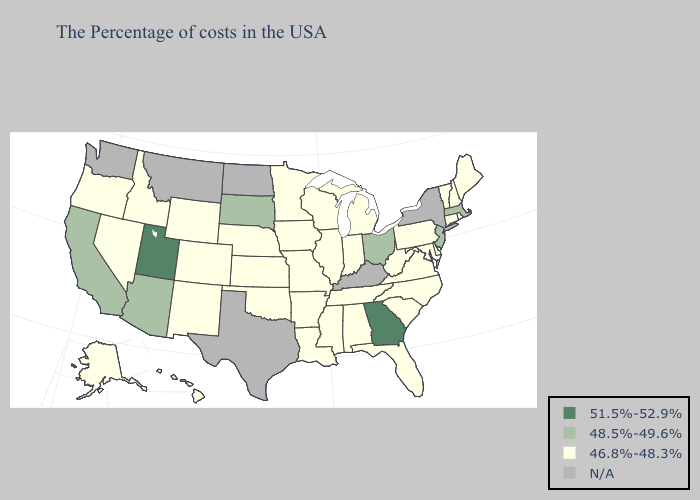What is the value of Georgia?
Keep it brief. 51.5%-52.9%. Name the states that have a value in the range N/A?
Quick response, please. New York, Kentucky, Texas, North Dakota, Montana, Washington. Name the states that have a value in the range N/A?
Be succinct. New York, Kentucky, Texas, North Dakota, Montana, Washington. Does Georgia have the highest value in the USA?
Write a very short answer. Yes. What is the highest value in states that border Arizona?
Answer briefly. 51.5%-52.9%. What is the highest value in the West ?
Be succinct. 51.5%-52.9%. What is the lowest value in the West?
Short answer required. 46.8%-48.3%. Name the states that have a value in the range 46.8%-48.3%?
Be succinct. Maine, Rhode Island, New Hampshire, Vermont, Connecticut, Delaware, Maryland, Pennsylvania, Virginia, North Carolina, South Carolina, West Virginia, Florida, Michigan, Indiana, Alabama, Tennessee, Wisconsin, Illinois, Mississippi, Louisiana, Missouri, Arkansas, Minnesota, Iowa, Kansas, Nebraska, Oklahoma, Wyoming, Colorado, New Mexico, Idaho, Nevada, Oregon, Alaska, Hawaii. What is the value of South Carolina?
Give a very brief answer. 46.8%-48.3%. What is the lowest value in states that border Montana?
Write a very short answer. 46.8%-48.3%. Among the states that border Oregon , which have the lowest value?
Answer briefly. Idaho, Nevada. Does Georgia have the highest value in the USA?
Give a very brief answer. Yes. Name the states that have a value in the range 51.5%-52.9%?
Give a very brief answer. Georgia, Utah. 